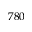<formula> <loc_0><loc_0><loc_500><loc_500>7 8 0</formula> 